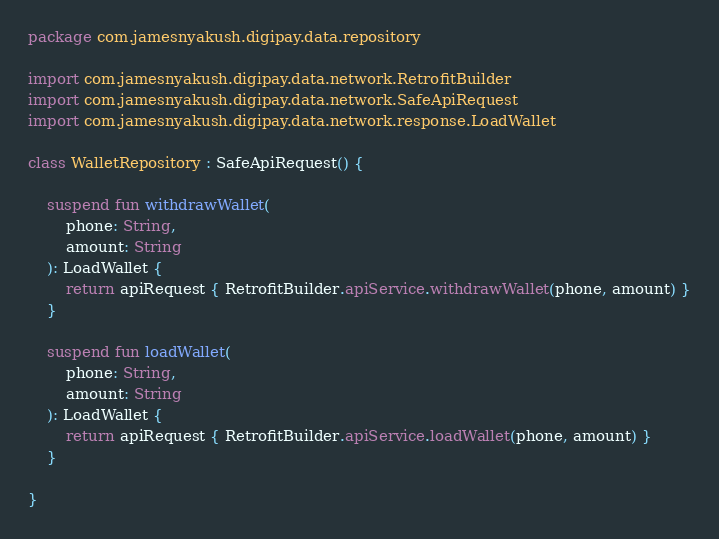Convert code to text. <code><loc_0><loc_0><loc_500><loc_500><_Kotlin_>package com.jamesnyakush.digipay.data.repository

import com.jamesnyakush.digipay.data.network.RetrofitBuilder
import com.jamesnyakush.digipay.data.network.SafeApiRequest
import com.jamesnyakush.digipay.data.network.response.LoadWallet

class WalletRepository : SafeApiRequest() {

    suspend fun withdrawWallet(
        phone: String,
        amount: String
    ): LoadWallet {
        return apiRequest { RetrofitBuilder.apiService.withdrawWallet(phone, amount) }
    }

    suspend fun loadWallet(
        phone: String,
        amount: String
    ): LoadWallet {
        return apiRequest { RetrofitBuilder.apiService.loadWallet(phone, amount) }
    }

}</code> 